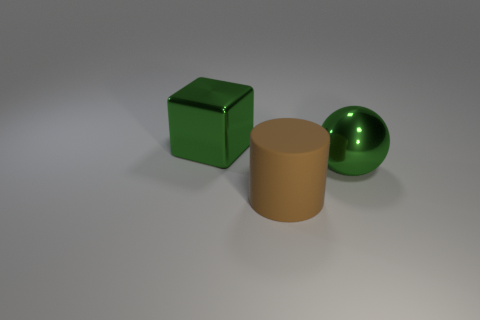What materials do the objects in the image appear to be made of? The objects in the image appear to be rendered with different material properties. The cube looks like it might be a green, shiny, metallic surface, the sphere has a smooth, reflective surface indicative of polished metal, and the cylinder appears to have a matte, possibly plastic texture. 